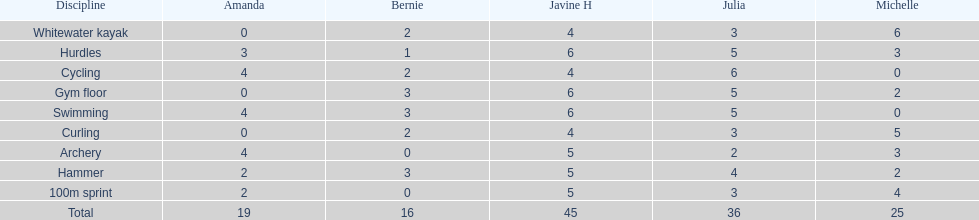What other girl besides amanda also had a 4 in cycling? Javine H. 